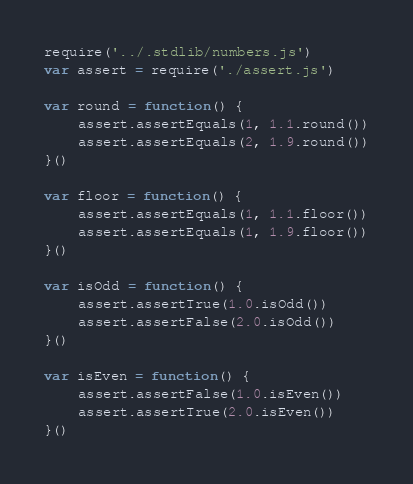Convert code to text. <code><loc_0><loc_0><loc_500><loc_500><_JavaScript_>require('../.stdlib/numbers.js')
var assert = require('./assert.js')

var round = function() {
    assert.assertEquals(1, 1.1.round())
    assert.assertEquals(2, 1.9.round())
}()

var floor = function() {
    assert.assertEquals(1, 1.1.floor())
    assert.assertEquals(1, 1.9.floor())
}()

var isOdd = function() {
    assert.assertTrue(1.0.isOdd())
    assert.assertFalse(2.0.isOdd())
}()

var isEven = function() {
    assert.assertFalse(1.0.isEven())
    assert.assertTrue(2.0.isEven())
}()</code> 